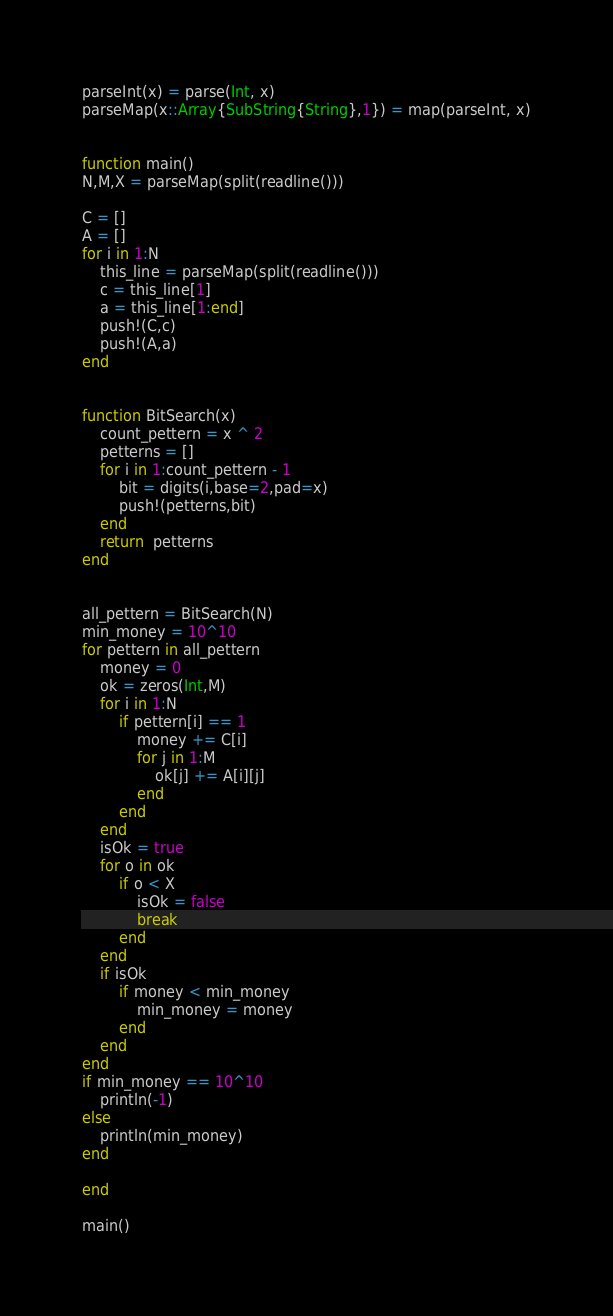<code> <loc_0><loc_0><loc_500><loc_500><_Julia_>parseInt(x) = parse(Int, x)
parseMap(x::Array{SubString{String},1}) = map(parseInt, x)


function main()
N,M,X = parseMap(split(readline()))

C = []
A = []
for i in 1:N
    this_line = parseMap(split(readline()))
    c = this_line[1]
    a = this_line[1:end]
    push!(C,c)
    push!(A,a)
end


function BitSearch(x)
    count_pettern = x ^ 2
    petterns = []
    for i in 1:count_pettern - 1
        bit = digits(i,base=2,pad=x)
        push!(petterns,bit)
    end
    return  petterns
end


all_pettern = BitSearch(N)
min_money = 10^10
for pettern in all_pettern
    money = 0
    ok = zeros(Int,M)
    for i in 1:N
        if pettern[i] == 1
            money += C[i]
            for j in 1:M
                ok[j] += A[i][j]
            end 
        end
    end
    isOk = true
    for o in ok
        if o < X
            isOk = false    
            break
        end
    end
    if isOk
        if money < min_money
            min_money = money
        end
    end
end
if min_money == 10^10
    println(-1)
else
    println(min_money)
end

end

main()</code> 